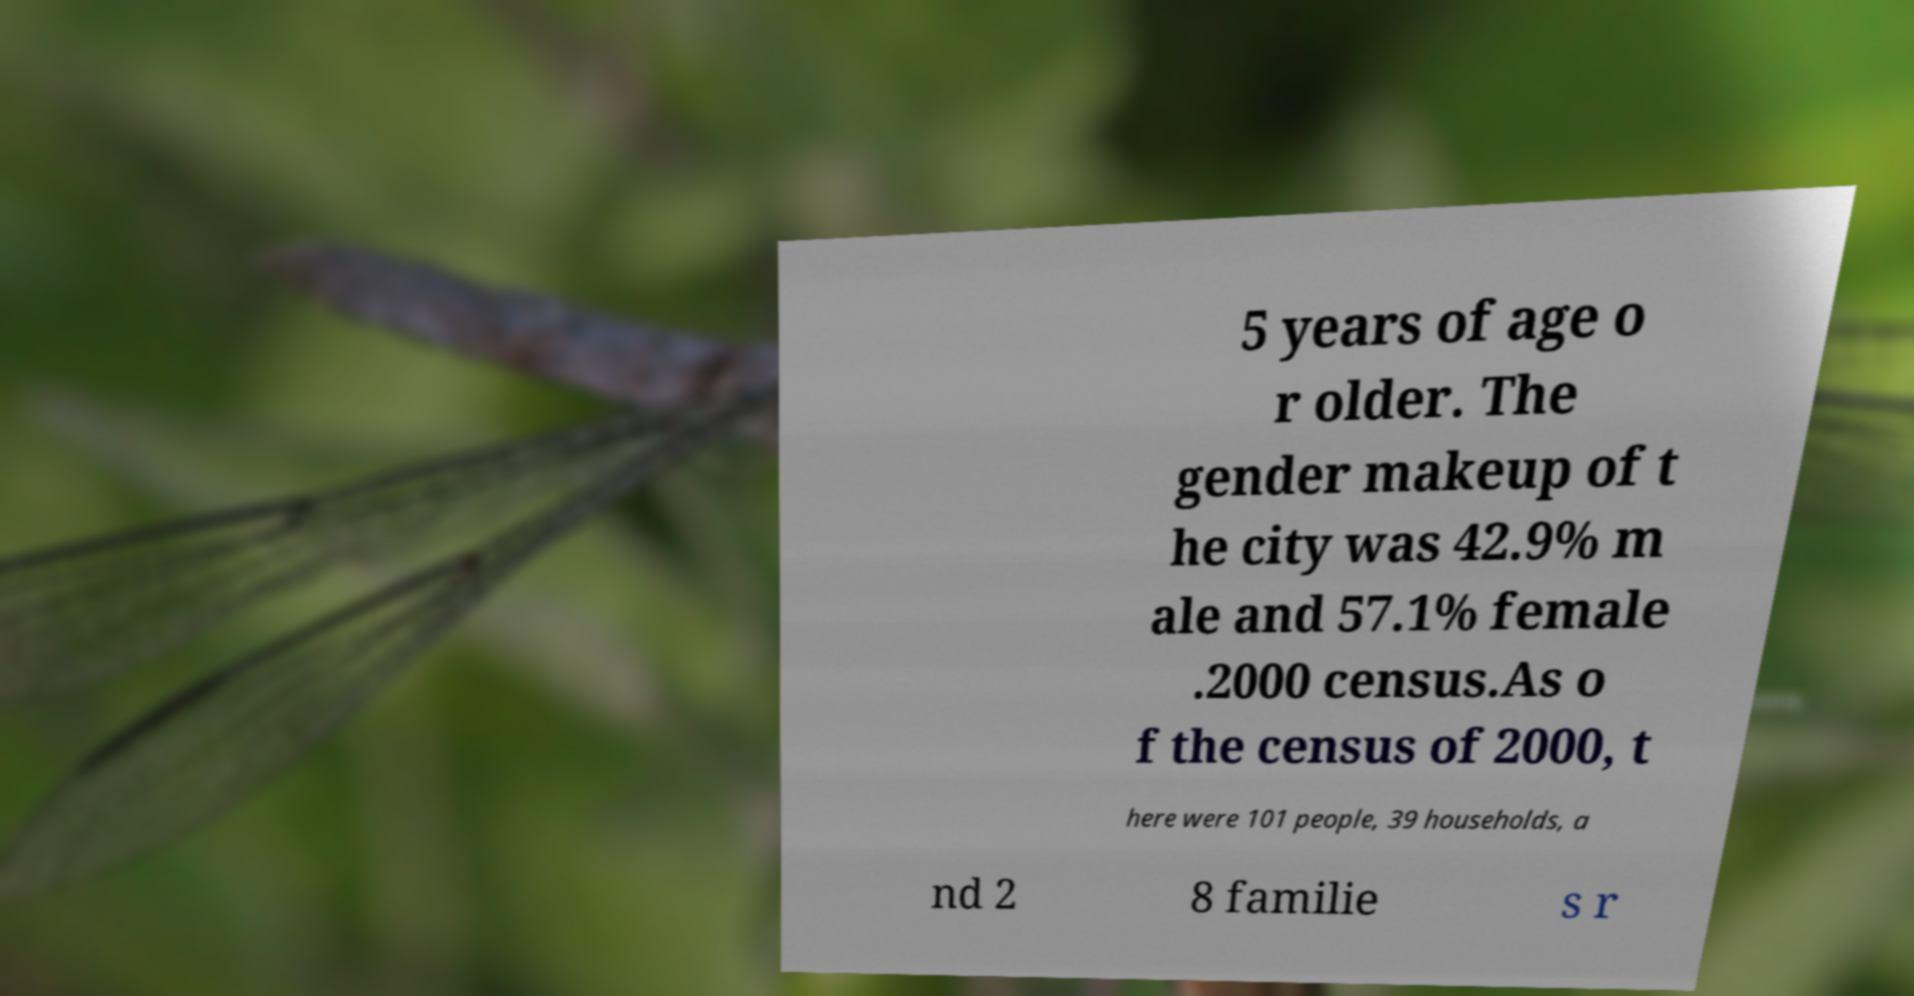Please read and relay the text visible in this image. What does it say? 5 years of age o r older. The gender makeup of t he city was 42.9% m ale and 57.1% female .2000 census.As o f the census of 2000, t here were 101 people, 39 households, a nd 2 8 familie s r 